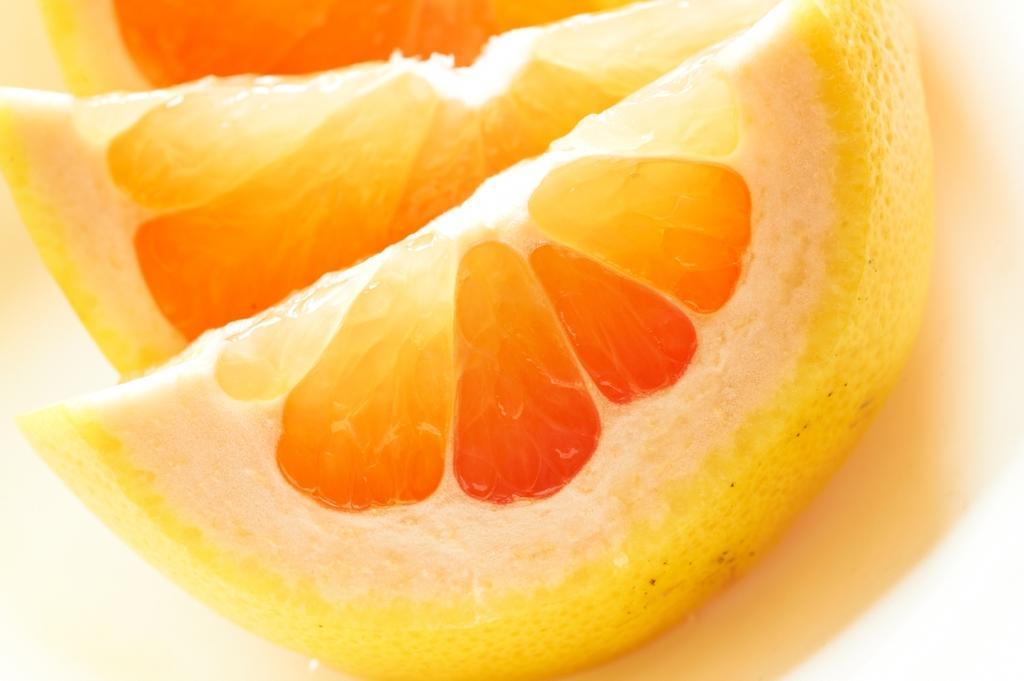Please provide a concise description of this image. In this image orange slices are present. 